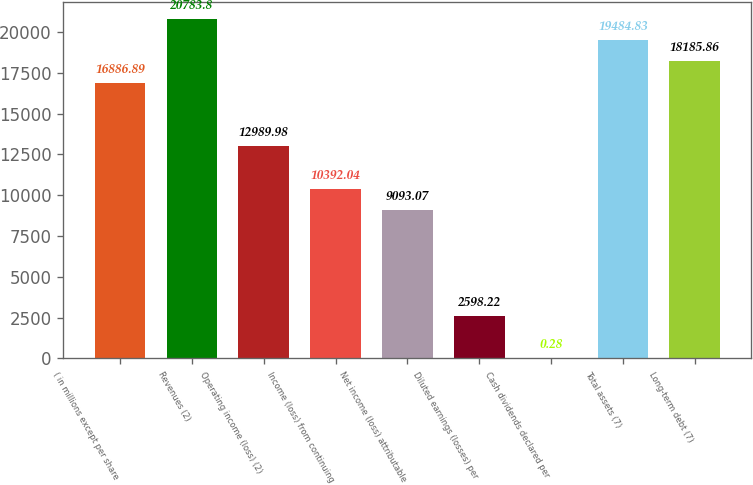<chart> <loc_0><loc_0><loc_500><loc_500><bar_chart><fcel>( in millions except per share<fcel>Revenues (2)<fcel>Operating income (loss) (2)<fcel>Income (loss) from continuing<fcel>Net income (loss) attributable<fcel>Diluted earnings (losses) per<fcel>Cash dividends declared per<fcel>Total assets (7)<fcel>Long-term debt (7)<nl><fcel>16886.9<fcel>20783.8<fcel>12990<fcel>10392<fcel>9093.07<fcel>2598.22<fcel>0.28<fcel>19484.8<fcel>18185.9<nl></chart> 